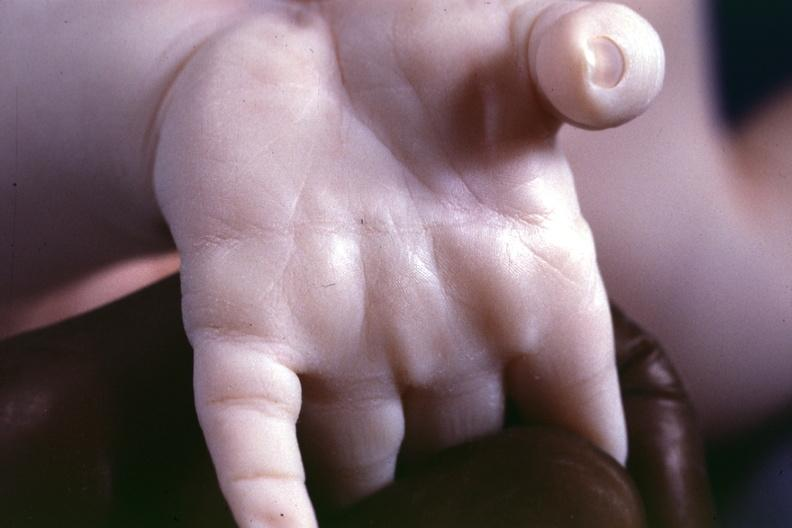re electron micrographs demonstrating fiber present?
Answer the question using a single word or phrase. No 